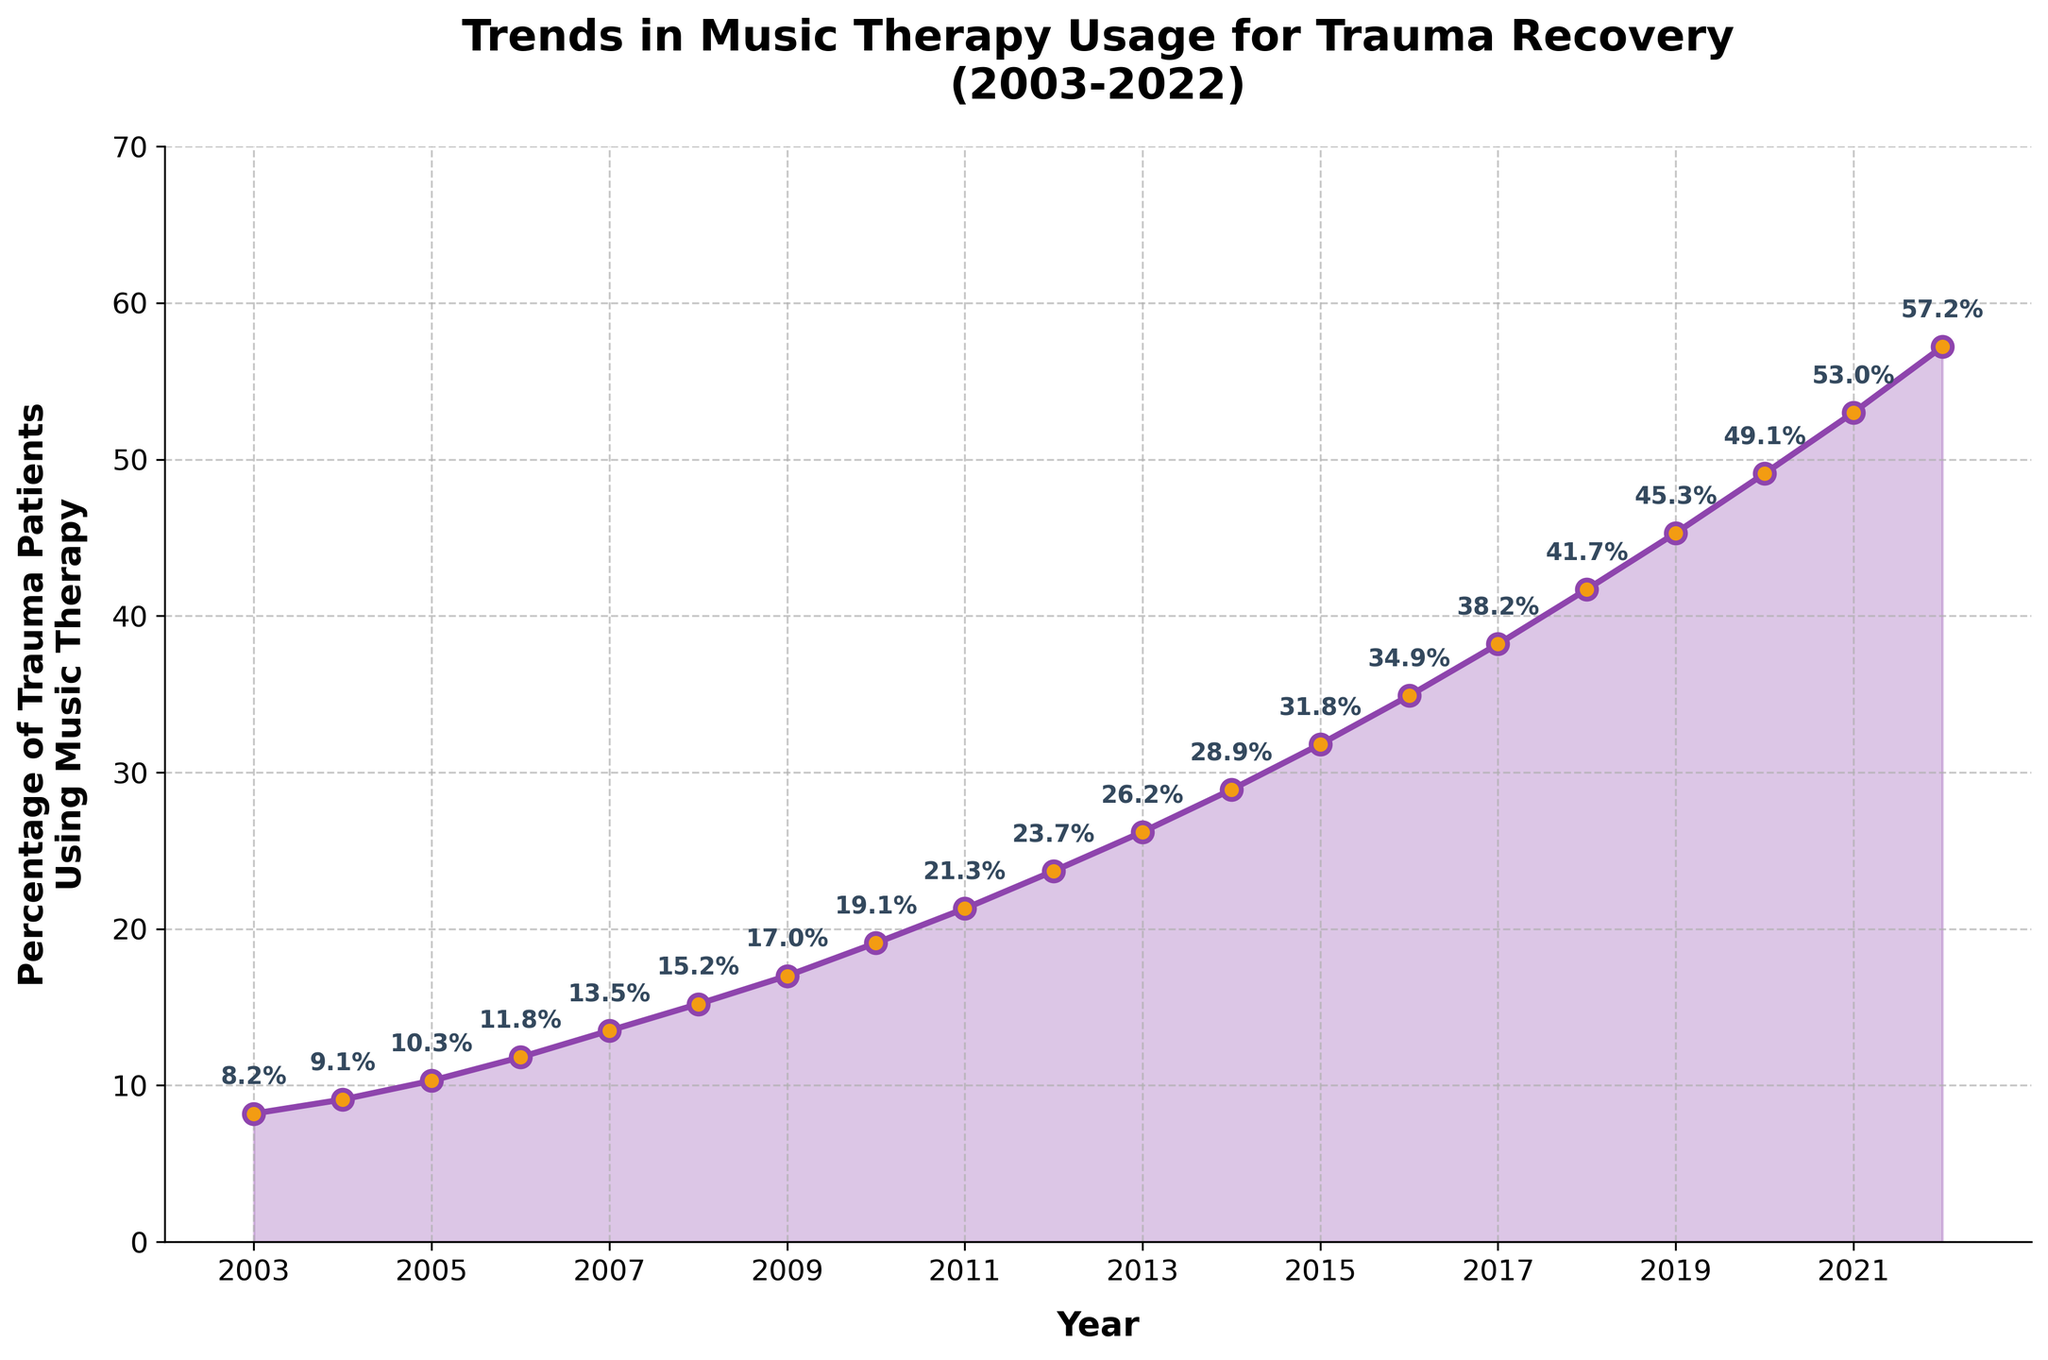What's the percentage of trauma patients using music therapy in 2015? Look at the data point for the year 2015; the corresponding percentage is given on the y-axis.
Answer: 31.8% How much did the usage percentage increase between 2003 and 2013? Find the percentages for the years 2003 and 2013, then subtract the 2003 value from the 2013 value: 26.2% - 8.2% = 18%.
Answer: 18% Which year had the highest percentage of trauma patients using music therapy? Visually inspect the graph for the highest point on the line and read the corresponding year.
Answer: 2022 What is the difference in usage percentage between the years 2010 and 2020? Locate the percentages for the years 2010 and 2020, and subtract the 2010 value from the 2020 value: 49.1% - 19.1% = 30%.
Answer: 30% Over the two decades, what is the average annual increase in the percentage of trauma patients using music therapy? Calculate the total increase by subtracting the 2003 value from the 2022 value, then divide by the number of years: (57.2% - 8.2%)/19 ≈ 2.58%.
Answer: 2.58% By how much did the percentage increase from 2008 to 2009? Look at the percentages for 2008 and 2009 and subtract the 2008 value from the 2009 value: 17.0% - 15.2% = 1.8%.
Answer: 1.8% Compare the usage increase between two 5-year periods: 2005-2010 and 2015-2020. Which period saw a higher increase? Calculate the increase for each period: (2010 value - 2005 value) and (2020 value - 2015 value). For 2005-2010: 19.1% - 10.3% = 8.8%. For 2015-2020: 49.1% - 31.8% = 17.3%. Comparatively, 2015-2020 had a higher increase.
Answer: 2015-2020 Which year saw the smallest increase in percentage from the previous year? Examine the consecutive year differences and locate the smallest increment. The smallest increase is between 2007 (13.5%) and 2008 (15.2%), which is 1.7%.
Answer: 2008 In which decade did the percentage of trauma patients using music therapy triple? Determine when the percentage starts and ends for each decade and find a tripling. From 2003 (8.2%) to 2013 (26.2%), the percentage more than tripled.
Answer: 2003-2013 How does the trend in music therapy usage change visually between the first and second decade? Observe the slope of the line from 2003-2012 and from 2013-2022. The trend is a steady increase in both periods, but faster in the second decade.
Answer: Faster growth in the second decade 